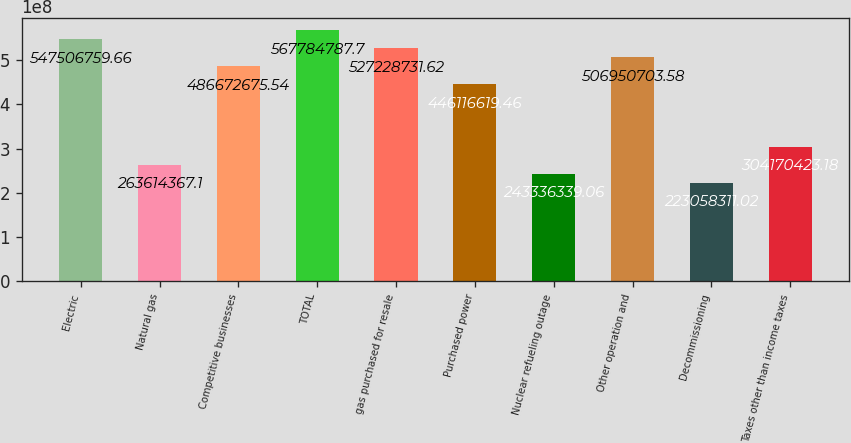<chart> <loc_0><loc_0><loc_500><loc_500><bar_chart><fcel>Electric<fcel>Natural gas<fcel>Competitive businesses<fcel>TOTAL<fcel>gas purchased for resale<fcel>Purchased power<fcel>Nuclear refueling outage<fcel>Other operation and<fcel>Decommissioning<fcel>Taxes other than income taxes<nl><fcel>5.47507e+08<fcel>2.63614e+08<fcel>4.86673e+08<fcel>5.67785e+08<fcel>5.27229e+08<fcel>4.46117e+08<fcel>2.43336e+08<fcel>5.06951e+08<fcel>2.23058e+08<fcel>3.0417e+08<nl></chart> 